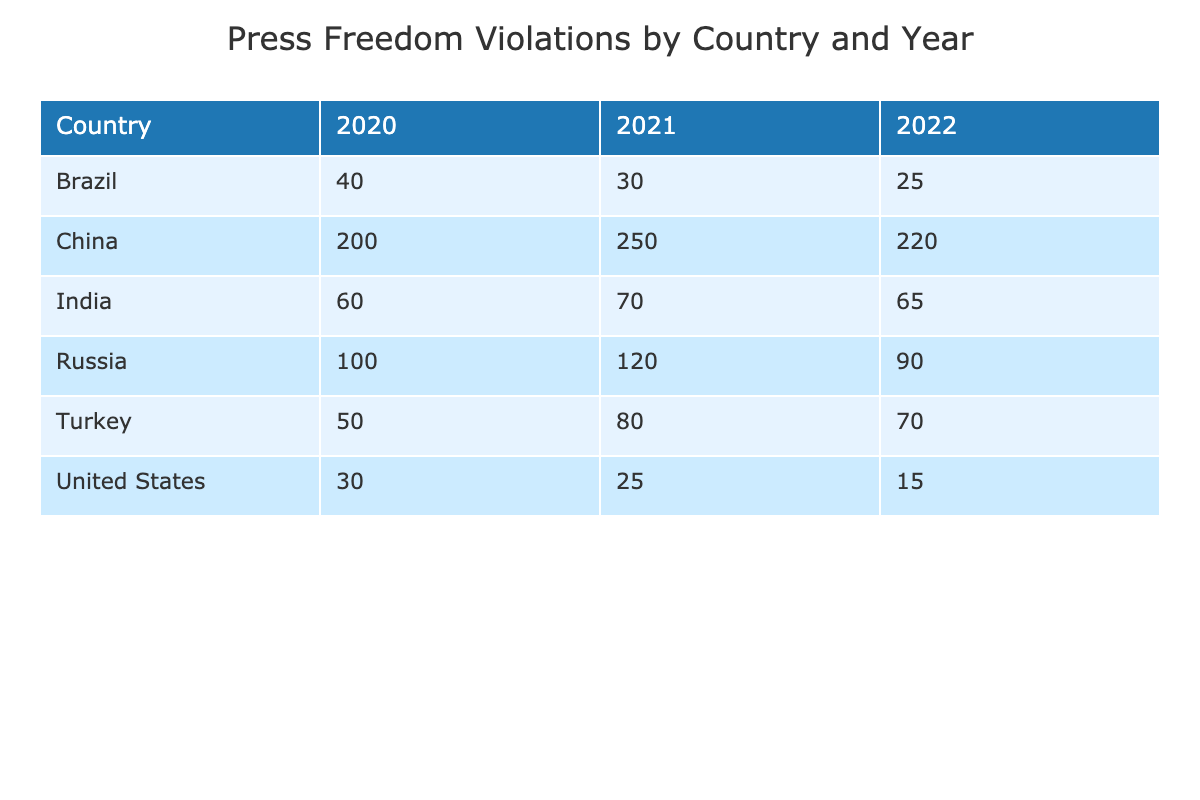What was the highest number of press freedom violations recorded in a single year for China? In 2021, China had the highest number of press freedom violations with 250 incidents, which is greater than the incidents recorded in other years.
Answer: 250 Which country had the lowest total number of press freedom violations across the three years? To find this, we sum the incidents for each country: United States (70), Russia (310), China (670), Turkey (200), Brazil (95), India (195). By comparing, the United States has the lowest total at 70 incidents.
Answer: United States Did Brazil experience an increase in the number of press freedom violations from 2020 to 2021? In 2020, Brazil had 40 incidents and in 2021, it had 30 incidents, indicating a decrease.
Answer: No What is the difference in press freedom violations between Turkey in 2021 and Turkey in 2022? Turkey had 80 violations in 2021 and 70 in 2022. The difference is calculated by subtracting the 2022 incidents from the 2021 incidents, which is 80 - 70 = 10.
Answer: 10 Which country had more incidents of violence against journalists in 2021, Turkey or the United States? Turkey had 80 incidents of violence against journalists in 2021, while the United States had 25. Comparing these values shows Turkey had significantly more incidents.
Answer: Turkey What was the average number of press freedom violations per year for Russia? Russia had violations of 100 in 2020, 120 in 2021, and 90 in 2022. The total is 100 + 120 + 90 = 310. There are three years, so the average is calculated as 310 / 3 = 103.33.
Answer: 103.33 Did any country experience a decrease in the number of censorship incidents from 2020 to 2022? By reviewing the data, Censorship incidents for the United States decreased from 30 in 2020 to 15 in 2022, which confirms a decrease in these incidents.
Answer: Yes Was there a year where China had fewer press freedom violations compared to the year before? Reviewing the years: in 2020, China had 200 incidents, in 2021 it increased to 250, and in 2022 it decreased to 220. Therefore, there was a decrease from 2021 to 2022, confirming a year with fewer violations.
Answer: Yes 